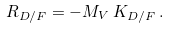<formula> <loc_0><loc_0><loc_500><loc_500>R _ { D / F } = - M _ { V } \, K _ { D / F } \, .</formula> 